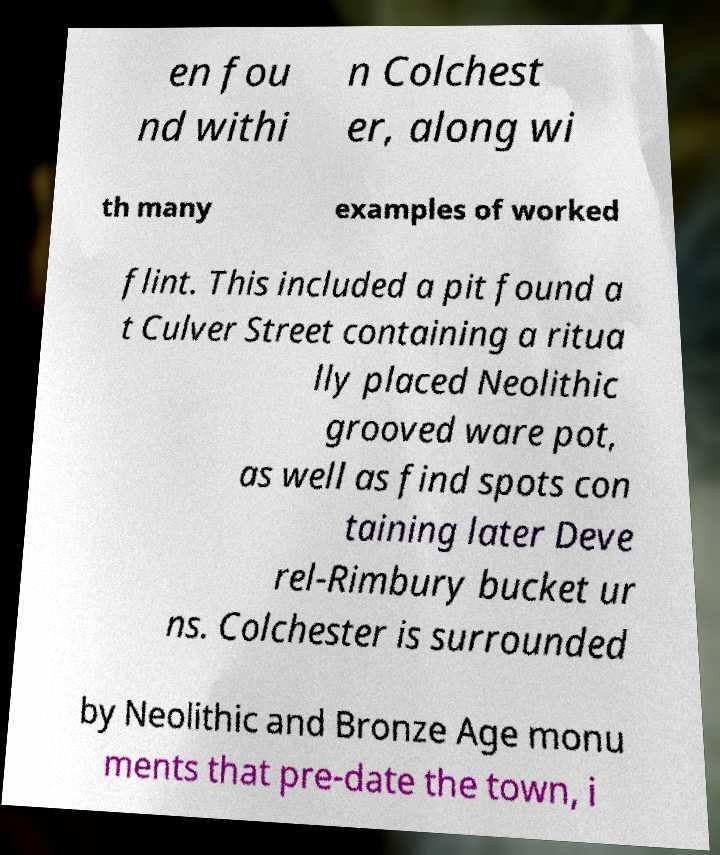Please identify and transcribe the text found in this image. en fou nd withi n Colchest er, along wi th many examples of worked flint. This included a pit found a t Culver Street containing a ritua lly placed Neolithic grooved ware pot, as well as find spots con taining later Deve rel-Rimbury bucket ur ns. Colchester is surrounded by Neolithic and Bronze Age monu ments that pre-date the town, i 